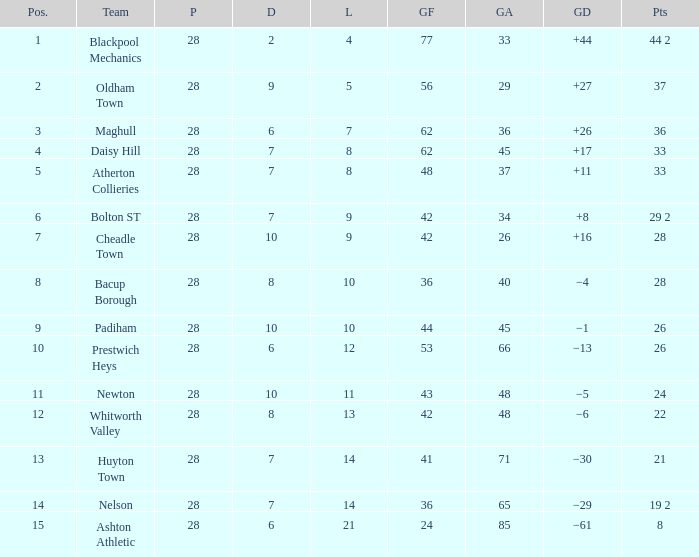What is the highest goals entry with drawn larger than 6 and goals against 85? None. 